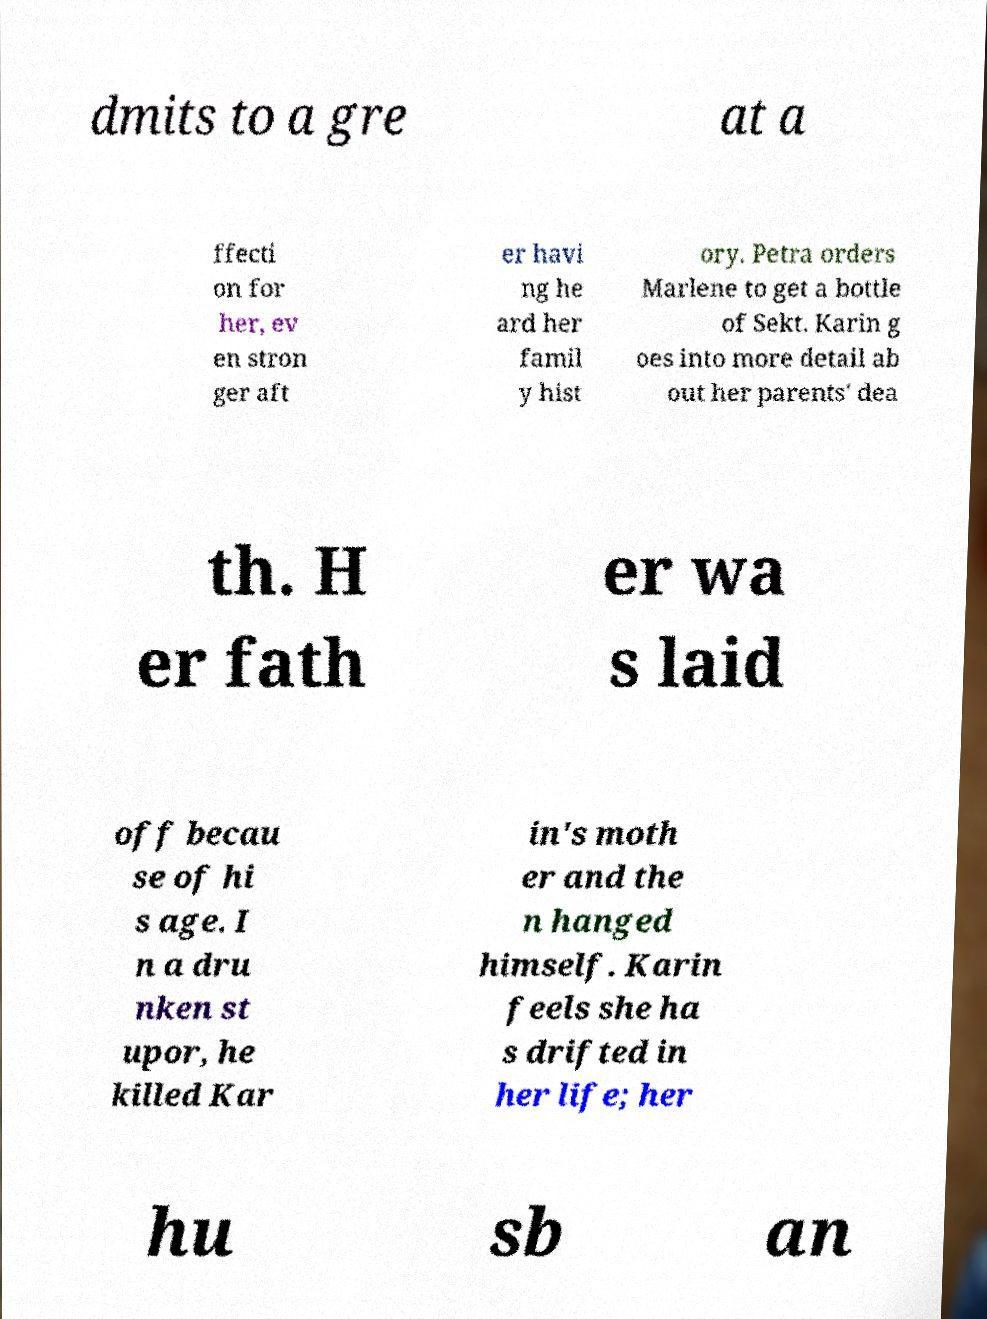For documentation purposes, I need the text within this image transcribed. Could you provide that? dmits to a gre at a ffecti on for her, ev en stron ger aft er havi ng he ard her famil y hist ory. Petra orders Marlene to get a bottle of Sekt. Karin g oes into more detail ab out her parents' dea th. H er fath er wa s laid off becau se of hi s age. I n a dru nken st upor, he killed Kar in's moth er and the n hanged himself. Karin feels she ha s drifted in her life; her hu sb an 